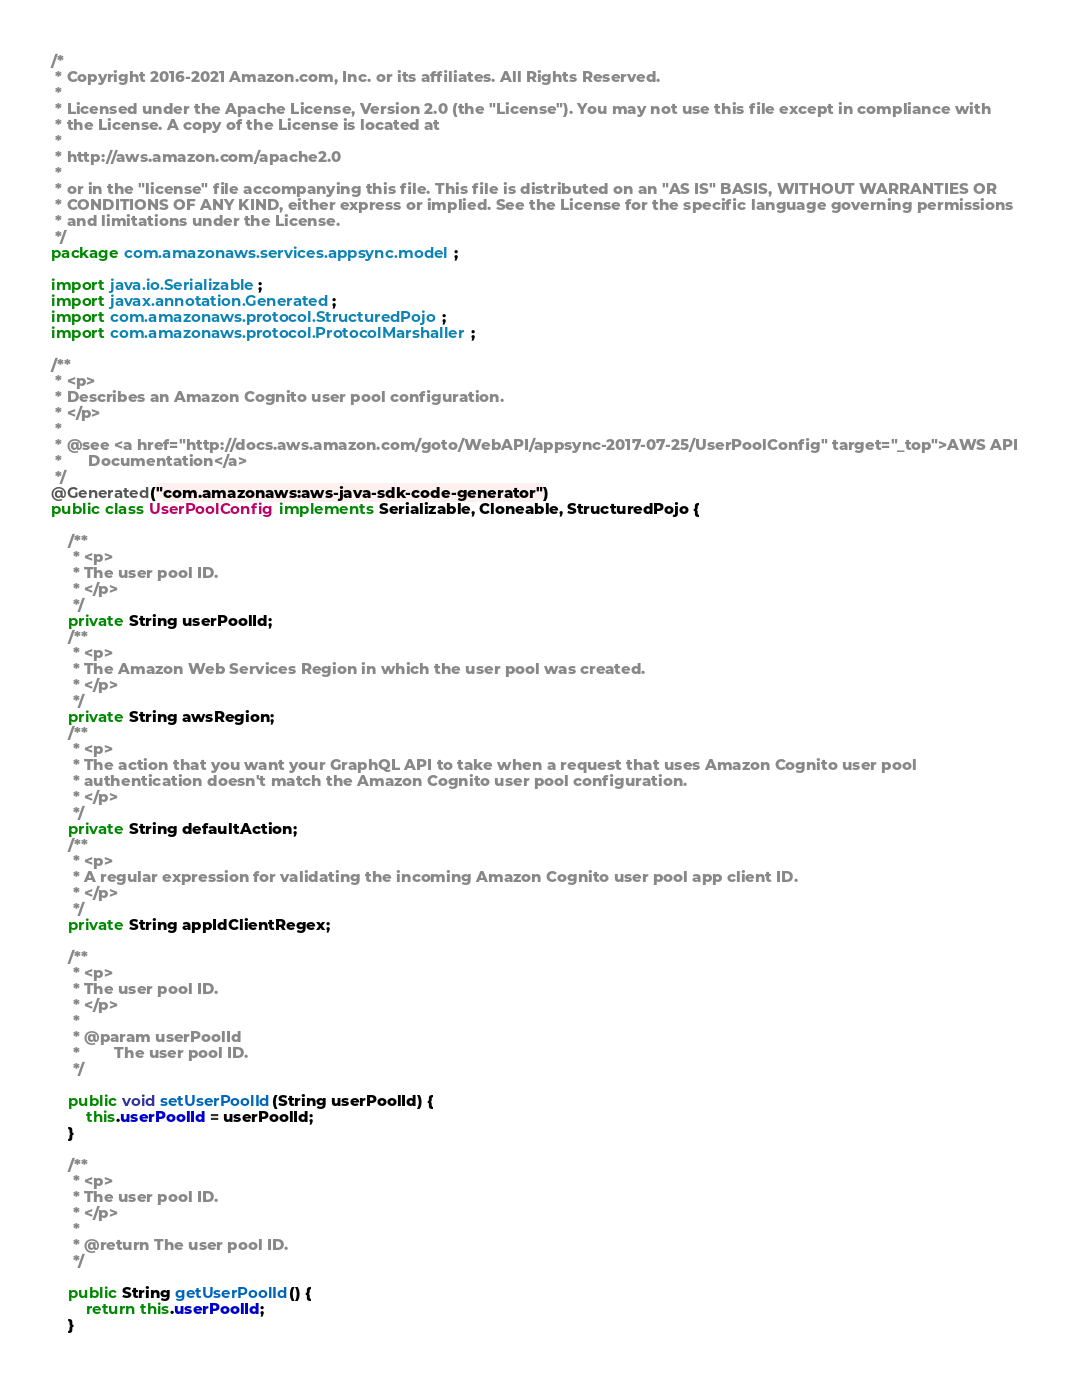<code> <loc_0><loc_0><loc_500><loc_500><_Java_>/*
 * Copyright 2016-2021 Amazon.com, Inc. or its affiliates. All Rights Reserved.
 * 
 * Licensed under the Apache License, Version 2.0 (the "License"). You may not use this file except in compliance with
 * the License. A copy of the License is located at
 * 
 * http://aws.amazon.com/apache2.0
 * 
 * or in the "license" file accompanying this file. This file is distributed on an "AS IS" BASIS, WITHOUT WARRANTIES OR
 * CONDITIONS OF ANY KIND, either express or implied. See the License for the specific language governing permissions
 * and limitations under the License.
 */
package com.amazonaws.services.appsync.model;

import java.io.Serializable;
import javax.annotation.Generated;
import com.amazonaws.protocol.StructuredPojo;
import com.amazonaws.protocol.ProtocolMarshaller;

/**
 * <p>
 * Describes an Amazon Cognito user pool configuration.
 * </p>
 * 
 * @see <a href="http://docs.aws.amazon.com/goto/WebAPI/appsync-2017-07-25/UserPoolConfig" target="_top">AWS API
 *      Documentation</a>
 */
@Generated("com.amazonaws:aws-java-sdk-code-generator")
public class UserPoolConfig implements Serializable, Cloneable, StructuredPojo {

    /**
     * <p>
     * The user pool ID.
     * </p>
     */
    private String userPoolId;
    /**
     * <p>
     * The Amazon Web Services Region in which the user pool was created.
     * </p>
     */
    private String awsRegion;
    /**
     * <p>
     * The action that you want your GraphQL API to take when a request that uses Amazon Cognito user pool
     * authentication doesn't match the Amazon Cognito user pool configuration.
     * </p>
     */
    private String defaultAction;
    /**
     * <p>
     * A regular expression for validating the incoming Amazon Cognito user pool app client ID.
     * </p>
     */
    private String appIdClientRegex;

    /**
     * <p>
     * The user pool ID.
     * </p>
     * 
     * @param userPoolId
     *        The user pool ID.
     */

    public void setUserPoolId(String userPoolId) {
        this.userPoolId = userPoolId;
    }

    /**
     * <p>
     * The user pool ID.
     * </p>
     * 
     * @return The user pool ID.
     */

    public String getUserPoolId() {
        return this.userPoolId;
    }
</code> 